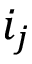<formula> <loc_0><loc_0><loc_500><loc_500>i _ { j }</formula> 